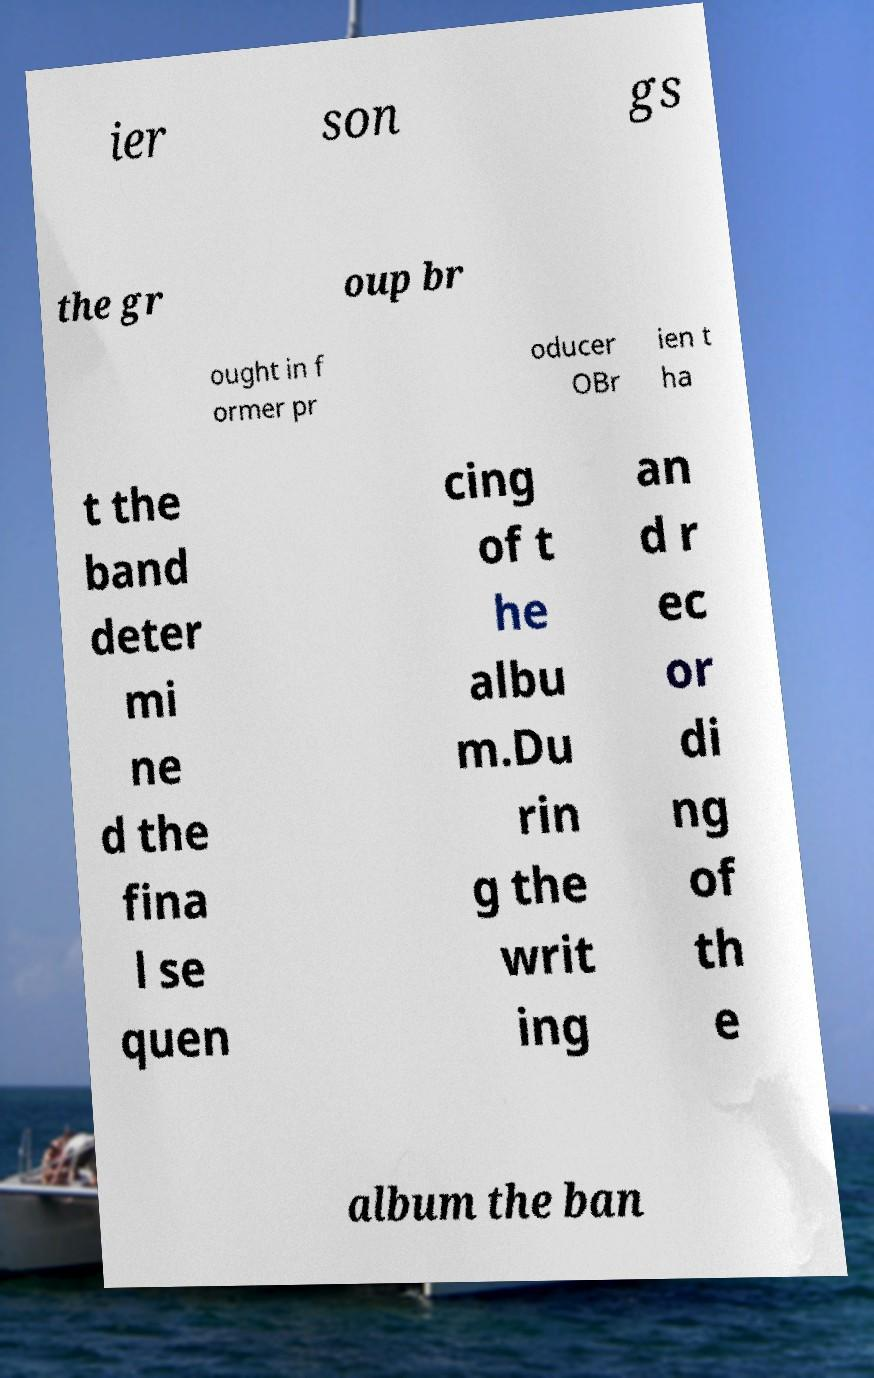For documentation purposes, I need the text within this image transcribed. Could you provide that? ier son gs the gr oup br ought in f ormer pr oducer OBr ien t ha t the band deter mi ne d the fina l se quen cing of t he albu m.Du rin g the writ ing an d r ec or di ng of th e album the ban 